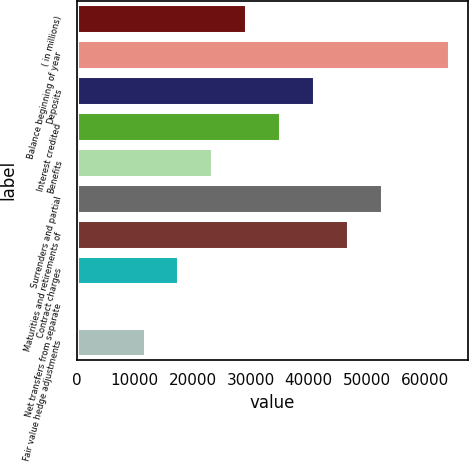Convert chart to OTSL. <chart><loc_0><loc_0><loc_500><loc_500><bar_chart><fcel>( in millions)<fcel>Balance beginning of year<fcel>Deposits<fcel>Interest credited<fcel>Benefits<fcel>Surrenders and partial<fcel>Maturities and retirements of<fcel>Contract charges<fcel>Net transfers from separate<fcel>Fair value hedge adjustments<nl><fcel>29212<fcel>64253.2<fcel>40892.4<fcel>35052.2<fcel>23371.8<fcel>52572.8<fcel>46732.6<fcel>17531.6<fcel>11<fcel>11691.4<nl></chart> 